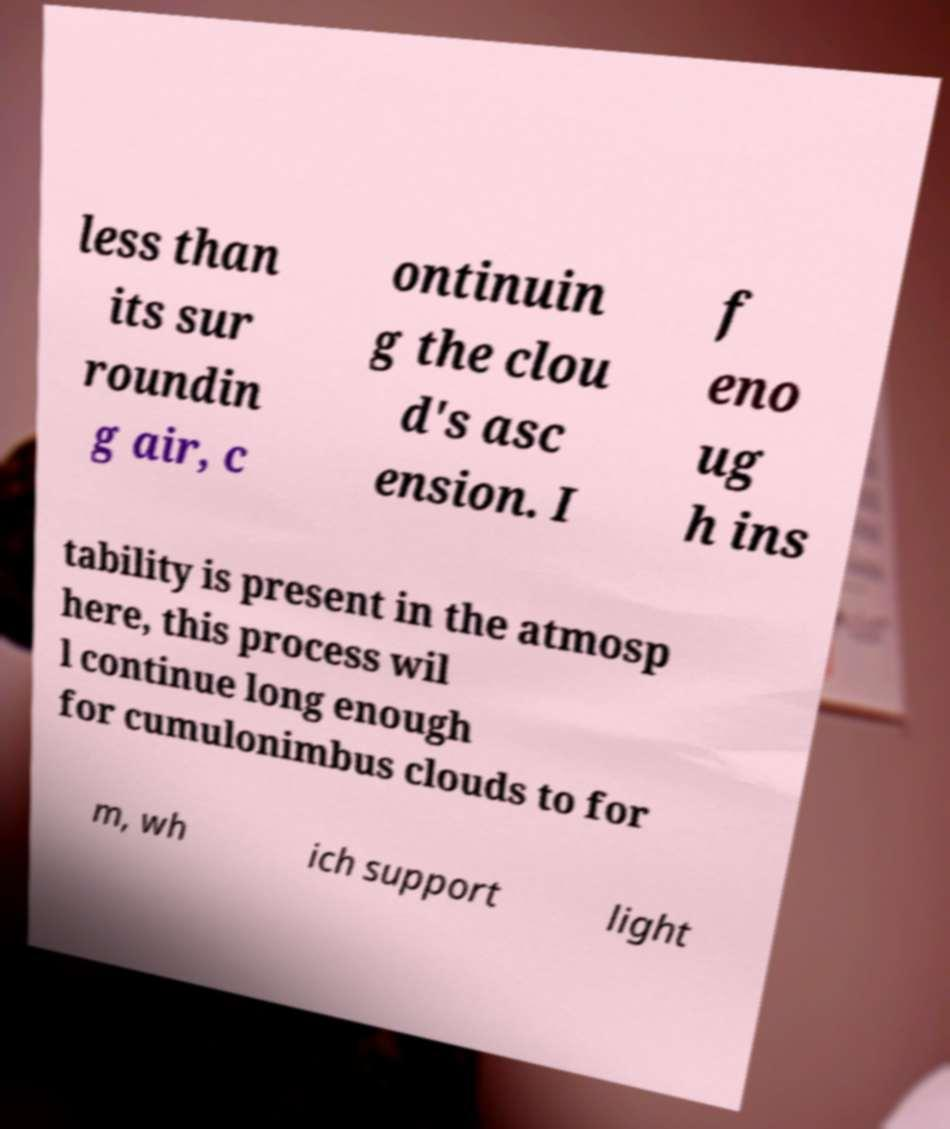Can you read and provide the text displayed in the image?This photo seems to have some interesting text. Can you extract and type it out for me? less than its sur roundin g air, c ontinuin g the clou d's asc ension. I f eno ug h ins tability is present in the atmosp here, this process wil l continue long enough for cumulonimbus clouds to for m, wh ich support light 